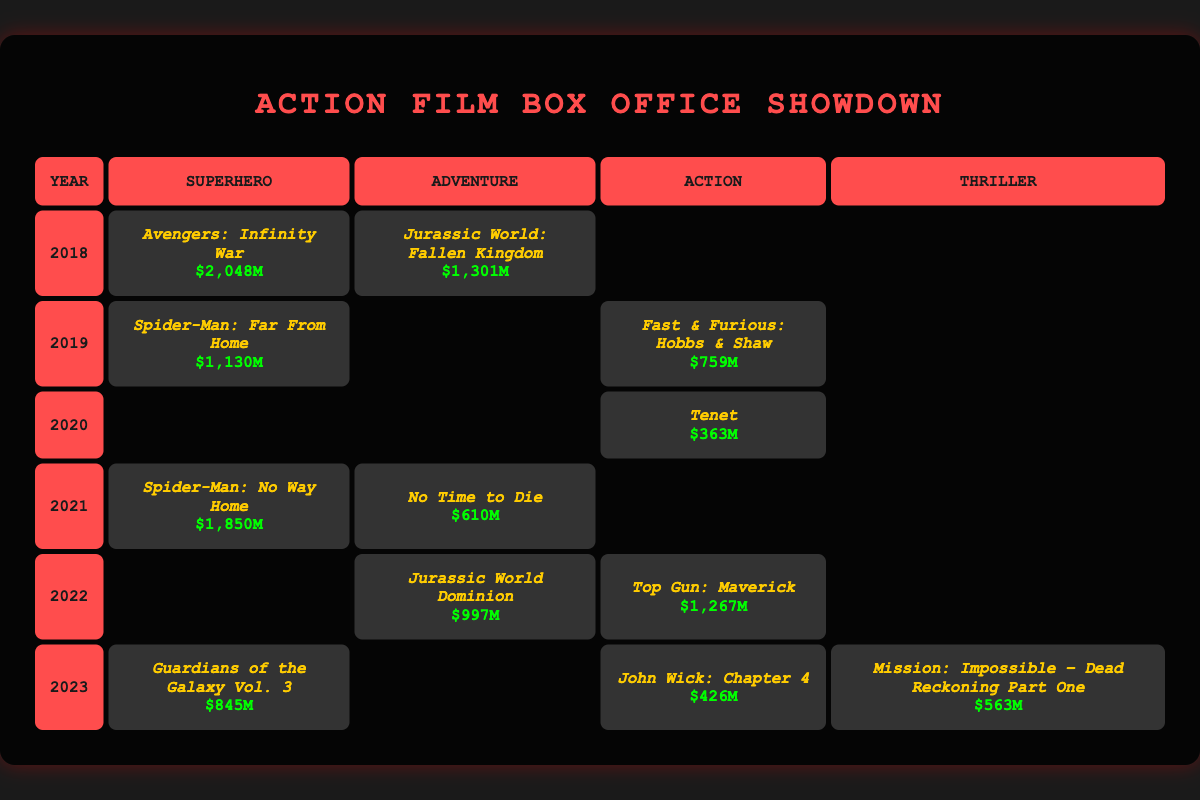what is the highest box office earning for any genre in 2018? In 2018, "Avengers: Infinity War" earned $2,048 million, making it the highest box office earning for that year.
Answer: $2,048 million which film had the lowest box office earnings in 2020? In 2020, "Tenet" had the lowest box office earnings at $363 million, as it is the only film listed for that year.
Answer: $363 million how much did "Spider-Man: No Way Home" earn compared to "No Time to Die"? "Spider-Man: No Way Home" earned $1,850 million, while "No Time to Die" earned $610 million. The difference is $1,850 million - $610 million = $1,240 million.
Answer: $1,240 million in which year did action films earn more on average, 2019 or 2022? In 2019, "Fast & Furious Presents: Hobbs & Shaw" earned $759 million, while in 2022, "Top Gun: Maverick" earned $1,267 million. To find the average, we consider only available action films. 2019 has one film with $759 million while 2022 has one film earning $1,267 million. Since $1,267 million is greater than $759 million, 2022 had a higher average.
Answer: 2022 how many superhero and action films were released in 2021? In 2021, there was one superhero film, "Spider-Man: No Way Home", and no action films listed. Therefore, the total is 1 superhero film and 0 action films.
Answer: 1 superhero film, 0 action films what genre had the highest cumulative box office earnings from 2018 to 2023? To find this, we sum the earnings per genre from all years listed. The revenue will be summed for each genre: Superhero ($2,048 + $1,130 + $1,850 + $845 = $5,973 million), Adventure ($1,301 + $610 + $997 = $2,908 million), Action ($759 + $363 + $1,267 + $426 = $2,815 million), Thriller ($563 million). The highest is Superhero with $5,973 million.
Answer: Superhero which film earned between $400 million and $500 million in 2023? In 2023, "John Wick: Chapter 4" earned $426 million, fitting the criteria of being between $400 million and $500 million.
Answer: John Wick: Chapter 4 was there any year without an action film release? Yes, in 2018 and 2021, there were no action films released according to the table data.
Answer: Yes what is the average box office earning for adventure films from 2018 to 2023? The adventure films released were "Jurassic World: Fallen Kingdom" ($1,301 million), "No Time to Die" ($610 million), and "Jurassic World Dominion" ($997 million). The average is calculated as (1,301 + 610 + 997) / 3 = 2,908 / 3 = $969.33 million.
Answer: $969.33 million how did the earnings of "Guardians of the Galaxy Vol. 3" compare to the combined earnings of both action films in 2022? "Guardians of the Galaxy Vol. 3" earned $845 million. The action films in 2022, "Top Gun: Maverick" ($1,267 million) and "John Wick: Chapter 4" ($426 million) total to $1,693 million. Since $845 million is less than $1,693 million, Guardians earned less than the combined action films.
Answer: It earned less 